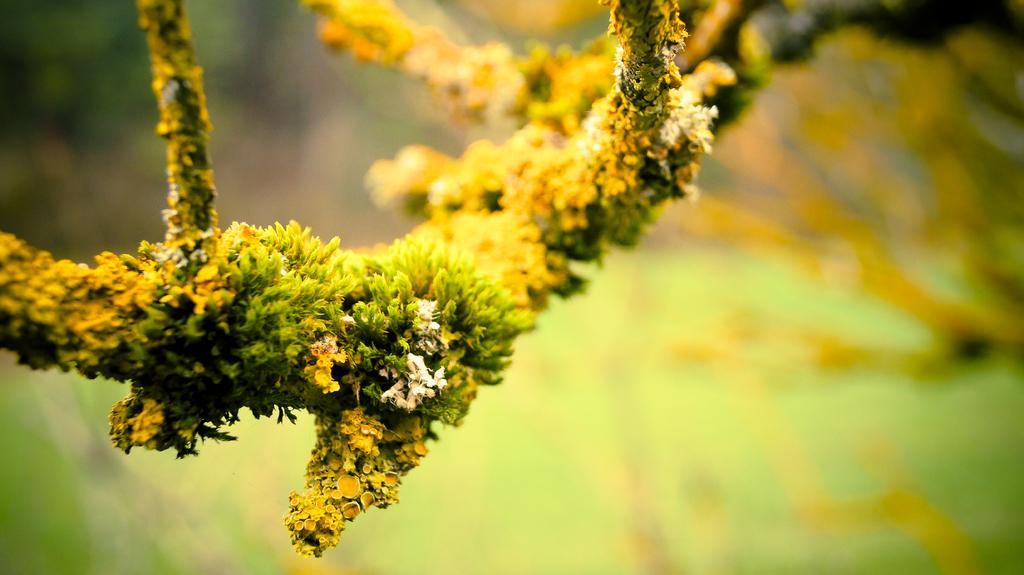Describe this image in one or two sentences. In the picture there is a branch of a larch tree and the background of the branch is blur. 